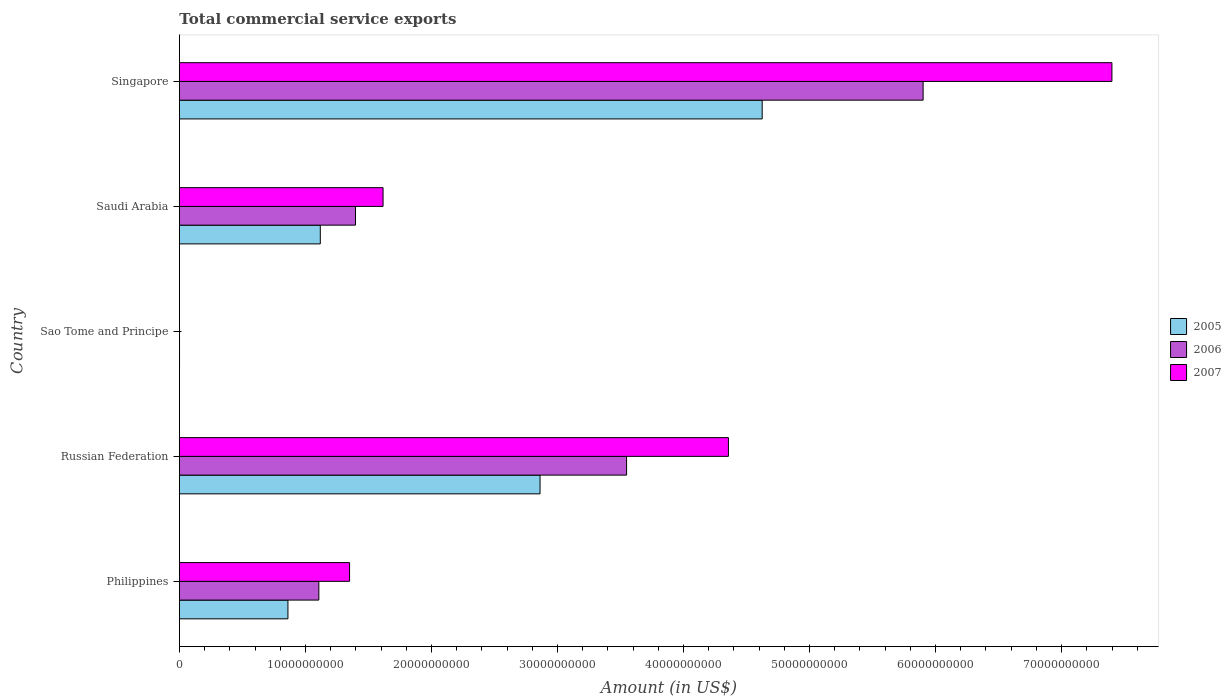How many different coloured bars are there?
Your answer should be compact. 3. Are the number of bars per tick equal to the number of legend labels?
Your answer should be compact. Yes. How many bars are there on the 1st tick from the top?
Ensure brevity in your answer.  3. What is the label of the 1st group of bars from the top?
Keep it short and to the point. Singapore. In how many cases, is the number of bars for a given country not equal to the number of legend labels?
Make the answer very short. 0. What is the total commercial service exports in 2005 in Philippines?
Offer a very short reply. 8.61e+09. Across all countries, what is the maximum total commercial service exports in 2005?
Give a very brief answer. 4.62e+1. Across all countries, what is the minimum total commercial service exports in 2007?
Give a very brief answer. 6.43e+06. In which country was the total commercial service exports in 2007 maximum?
Offer a terse response. Singapore. In which country was the total commercial service exports in 2007 minimum?
Offer a very short reply. Sao Tome and Principe. What is the total total commercial service exports in 2007 in the graph?
Your answer should be compact. 1.47e+11. What is the difference between the total commercial service exports in 2006 in Philippines and that in Singapore?
Give a very brief answer. -4.79e+1. What is the difference between the total commercial service exports in 2005 in Saudi Arabia and the total commercial service exports in 2007 in Philippines?
Make the answer very short. -2.32e+09. What is the average total commercial service exports in 2005 per country?
Give a very brief answer. 1.89e+1. What is the difference between the total commercial service exports in 2006 and total commercial service exports in 2005 in Russian Federation?
Make the answer very short. 6.87e+09. In how many countries, is the total commercial service exports in 2007 greater than 16000000000 US$?
Your response must be concise. 3. What is the ratio of the total commercial service exports in 2005 in Sao Tome and Principe to that in Singapore?
Make the answer very short. 0. Is the total commercial service exports in 2007 in Russian Federation less than that in Singapore?
Your answer should be very brief. Yes. What is the difference between the highest and the second highest total commercial service exports in 2006?
Give a very brief answer. 2.35e+1. What is the difference between the highest and the lowest total commercial service exports in 2005?
Give a very brief answer. 4.62e+1. What does the 2nd bar from the top in Philippines represents?
Ensure brevity in your answer.  2006. Is it the case that in every country, the sum of the total commercial service exports in 2006 and total commercial service exports in 2007 is greater than the total commercial service exports in 2005?
Offer a very short reply. Yes. Are all the bars in the graph horizontal?
Provide a succinct answer. Yes. How many countries are there in the graph?
Give a very brief answer. 5. What is the difference between two consecutive major ticks on the X-axis?
Your response must be concise. 1.00e+1. Are the values on the major ticks of X-axis written in scientific E-notation?
Your answer should be very brief. No. How many legend labels are there?
Offer a very short reply. 3. How are the legend labels stacked?
Provide a succinct answer. Vertical. What is the title of the graph?
Your answer should be compact. Total commercial service exports. What is the Amount (in US$) of 2005 in Philippines?
Provide a short and direct response. 8.61e+09. What is the Amount (in US$) of 2006 in Philippines?
Make the answer very short. 1.11e+1. What is the Amount (in US$) in 2007 in Philippines?
Provide a short and direct response. 1.35e+1. What is the Amount (in US$) in 2005 in Russian Federation?
Ensure brevity in your answer.  2.86e+1. What is the Amount (in US$) in 2006 in Russian Federation?
Keep it short and to the point. 3.55e+1. What is the Amount (in US$) of 2007 in Russian Federation?
Offer a terse response. 4.36e+1. What is the Amount (in US$) of 2005 in Sao Tome and Principe?
Offer a terse response. 8.86e+06. What is the Amount (in US$) in 2006 in Sao Tome and Principe?
Your answer should be very brief. 8.14e+06. What is the Amount (in US$) in 2007 in Sao Tome and Principe?
Offer a very short reply. 6.43e+06. What is the Amount (in US$) in 2005 in Saudi Arabia?
Your response must be concise. 1.12e+1. What is the Amount (in US$) of 2006 in Saudi Arabia?
Offer a very short reply. 1.40e+1. What is the Amount (in US$) in 2007 in Saudi Arabia?
Offer a terse response. 1.62e+1. What is the Amount (in US$) in 2005 in Singapore?
Keep it short and to the point. 4.62e+1. What is the Amount (in US$) in 2006 in Singapore?
Provide a succinct answer. 5.90e+1. What is the Amount (in US$) of 2007 in Singapore?
Offer a terse response. 7.40e+1. Across all countries, what is the maximum Amount (in US$) in 2005?
Your answer should be compact. 4.62e+1. Across all countries, what is the maximum Amount (in US$) of 2006?
Your answer should be compact. 5.90e+1. Across all countries, what is the maximum Amount (in US$) of 2007?
Provide a short and direct response. 7.40e+1. Across all countries, what is the minimum Amount (in US$) of 2005?
Give a very brief answer. 8.86e+06. Across all countries, what is the minimum Amount (in US$) of 2006?
Your answer should be very brief. 8.14e+06. Across all countries, what is the minimum Amount (in US$) in 2007?
Your response must be concise. 6.43e+06. What is the total Amount (in US$) in 2005 in the graph?
Your response must be concise. 9.47e+1. What is the total Amount (in US$) of 2006 in the graph?
Provide a short and direct response. 1.20e+11. What is the total Amount (in US$) in 2007 in the graph?
Make the answer very short. 1.47e+11. What is the difference between the Amount (in US$) in 2005 in Philippines and that in Russian Federation?
Ensure brevity in your answer.  -2.00e+1. What is the difference between the Amount (in US$) in 2006 in Philippines and that in Russian Federation?
Offer a terse response. -2.44e+1. What is the difference between the Amount (in US$) of 2007 in Philippines and that in Russian Federation?
Offer a terse response. -3.01e+1. What is the difference between the Amount (in US$) of 2005 in Philippines and that in Sao Tome and Principe?
Ensure brevity in your answer.  8.60e+09. What is the difference between the Amount (in US$) in 2006 in Philippines and that in Sao Tome and Principe?
Offer a very short reply. 1.11e+1. What is the difference between the Amount (in US$) of 2007 in Philippines and that in Sao Tome and Principe?
Make the answer very short. 1.35e+1. What is the difference between the Amount (in US$) in 2005 in Philippines and that in Saudi Arabia?
Your answer should be compact. -2.57e+09. What is the difference between the Amount (in US$) in 2006 in Philippines and that in Saudi Arabia?
Ensure brevity in your answer.  -2.91e+09. What is the difference between the Amount (in US$) in 2007 in Philippines and that in Saudi Arabia?
Your answer should be very brief. -2.66e+09. What is the difference between the Amount (in US$) in 2005 in Philippines and that in Singapore?
Provide a short and direct response. -3.76e+1. What is the difference between the Amount (in US$) in 2006 in Philippines and that in Singapore?
Offer a terse response. -4.79e+1. What is the difference between the Amount (in US$) of 2007 in Philippines and that in Singapore?
Your response must be concise. -6.05e+1. What is the difference between the Amount (in US$) of 2005 in Russian Federation and that in Sao Tome and Principe?
Ensure brevity in your answer.  2.86e+1. What is the difference between the Amount (in US$) of 2006 in Russian Federation and that in Sao Tome and Principe?
Provide a short and direct response. 3.55e+1. What is the difference between the Amount (in US$) in 2007 in Russian Federation and that in Sao Tome and Principe?
Offer a very short reply. 4.36e+1. What is the difference between the Amount (in US$) of 2005 in Russian Federation and that in Saudi Arabia?
Your response must be concise. 1.74e+1. What is the difference between the Amount (in US$) of 2006 in Russian Federation and that in Saudi Arabia?
Provide a succinct answer. 2.15e+1. What is the difference between the Amount (in US$) in 2007 in Russian Federation and that in Saudi Arabia?
Your response must be concise. 2.74e+1. What is the difference between the Amount (in US$) in 2005 in Russian Federation and that in Singapore?
Make the answer very short. -1.76e+1. What is the difference between the Amount (in US$) of 2006 in Russian Federation and that in Singapore?
Your answer should be compact. -2.35e+1. What is the difference between the Amount (in US$) of 2007 in Russian Federation and that in Singapore?
Offer a terse response. -3.04e+1. What is the difference between the Amount (in US$) of 2005 in Sao Tome and Principe and that in Saudi Arabia?
Your response must be concise. -1.12e+1. What is the difference between the Amount (in US$) in 2006 in Sao Tome and Principe and that in Saudi Arabia?
Keep it short and to the point. -1.40e+1. What is the difference between the Amount (in US$) of 2007 in Sao Tome and Principe and that in Saudi Arabia?
Your answer should be very brief. -1.62e+1. What is the difference between the Amount (in US$) of 2005 in Sao Tome and Principe and that in Singapore?
Offer a very short reply. -4.62e+1. What is the difference between the Amount (in US$) of 2006 in Sao Tome and Principe and that in Singapore?
Keep it short and to the point. -5.90e+1. What is the difference between the Amount (in US$) in 2007 in Sao Tome and Principe and that in Singapore?
Provide a short and direct response. -7.40e+1. What is the difference between the Amount (in US$) of 2005 in Saudi Arabia and that in Singapore?
Give a very brief answer. -3.51e+1. What is the difference between the Amount (in US$) in 2006 in Saudi Arabia and that in Singapore?
Your answer should be compact. -4.50e+1. What is the difference between the Amount (in US$) in 2007 in Saudi Arabia and that in Singapore?
Your answer should be very brief. -5.78e+1. What is the difference between the Amount (in US$) of 2005 in Philippines and the Amount (in US$) of 2006 in Russian Federation?
Provide a short and direct response. -2.69e+1. What is the difference between the Amount (in US$) of 2005 in Philippines and the Amount (in US$) of 2007 in Russian Federation?
Make the answer very short. -3.50e+1. What is the difference between the Amount (in US$) of 2006 in Philippines and the Amount (in US$) of 2007 in Russian Federation?
Your response must be concise. -3.25e+1. What is the difference between the Amount (in US$) in 2005 in Philippines and the Amount (in US$) in 2006 in Sao Tome and Principe?
Offer a very short reply. 8.60e+09. What is the difference between the Amount (in US$) in 2005 in Philippines and the Amount (in US$) in 2007 in Sao Tome and Principe?
Give a very brief answer. 8.60e+09. What is the difference between the Amount (in US$) of 2006 in Philippines and the Amount (in US$) of 2007 in Sao Tome and Principe?
Make the answer very short. 1.11e+1. What is the difference between the Amount (in US$) of 2005 in Philippines and the Amount (in US$) of 2006 in Saudi Arabia?
Provide a succinct answer. -5.36e+09. What is the difference between the Amount (in US$) in 2005 in Philippines and the Amount (in US$) in 2007 in Saudi Arabia?
Give a very brief answer. -7.55e+09. What is the difference between the Amount (in US$) of 2006 in Philippines and the Amount (in US$) of 2007 in Saudi Arabia?
Keep it short and to the point. -5.10e+09. What is the difference between the Amount (in US$) of 2005 in Philippines and the Amount (in US$) of 2006 in Singapore?
Provide a succinct answer. -5.04e+1. What is the difference between the Amount (in US$) of 2005 in Philippines and the Amount (in US$) of 2007 in Singapore?
Your answer should be very brief. -6.54e+1. What is the difference between the Amount (in US$) in 2006 in Philippines and the Amount (in US$) in 2007 in Singapore?
Make the answer very short. -6.29e+1. What is the difference between the Amount (in US$) in 2005 in Russian Federation and the Amount (in US$) in 2006 in Sao Tome and Principe?
Provide a succinct answer. 2.86e+1. What is the difference between the Amount (in US$) in 2005 in Russian Federation and the Amount (in US$) in 2007 in Sao Tome and Principe?
Offer a terse response. 2.86e+1. What is the difference between the Amount (in US$) in 2006 in Russian Federation and the Amount (in US$) in 2007 in Sao Tome and Principe?
Your answer should be very brief. 3.55e+1. What is the difference between the Amount (in US$) in 2005 in Russian Federation and the Amount (in US$) in 2006 in Saudi Arabia?
Your response must be concise. 1.46e+1. What is the difference between the Amount (in US$) in 2005 in Russian Federation and the Amount (in US$) in 2007 in Saudi Arabia?
Ensure brevity in your answer.  1.25e+1. What is the difference between the Amount (in US$) of 2006 in Russian Federation and the Amount (in US$) of 2007 in Saudi Arabia?
Make the answer very short. 1.93e+1. What is the difference between the Amount (in US$) in 2005 in Russian Federation and the Amount (in US$) in 2006 in Singapore?
Give a very brief answer. -3.04e+1. What is the difference between the Amount (in US$) of 2005 in Russian Federation and the Amount (in US$) of 2007 in Singapore?
Your answer should be very brief. -4.54e+1. What is the difference between the Amount (in US$) in 2006 in Russian Federation and the Amount (in US$) in 2007 in Singapore?
Keep it short and to the point. -3.85e+1. What is the difference between the Amount (in US$) in 2005 in Sao Tome and Principe and the Amount (in US$) in 2006 in Saudi Arabia?
Provide a succinct answer. -1.40e+1. What is the difference between the Amount (in US$) of 2005 in Sao Tome and Principe and the Amount (in US$) of 2007 in Saudi Arabia?
Offer a very short reply. -1.62e+1. What is the difference between the Amount (in US$) in 2006 in Sao Tome and Principe and the Amount (in US$) in 2007 in Saudi Arabia?
Provide a succinct answer. -1.62e+1. What is the difference between the Amount (in US$) of 2005 in Sao Tome and Principe and the Amount (in US$) of 2006 in Singapore?
Ensure brevity in your answer.  -5.90e+1. What is the difference between the Amount (in US$) of 2005 in Sao Tome and Principe and the Amount (in US$) of 2007 in Singapore?
Your response must be concise. -7.40e+1. What is the difference between the Amount (in US$) of 2006 in Sao Tome and Principe and the Amount (in US$) of 2007 in Singapore?
Offer a very short reply. -7.40e+1. What is the difference between the Amount (in US$) of 2005 in Saudi Arabia and the Amount (in US$) of 2006 in Singapore?
Make the answer very short. -4.78e+1. What is the difference between the Amount (in US$) of 2005 in Saudi Arabia and the Amount (in US$) of 2007 in Singapore?
Provide a short and direct response. -6.28e+1. What is the difference between the Amount (in US$) of 2006 in Saudi Arabia and the Amount (in US$) of 2007 in Singapore?
Offer a terse response. -6.00e+1. What is the average Amount (in US$) of 2005 per country?
Make the answer very short. 1.89e+1. What is the average Amount (in US$) of 2006 per country?
Keep it short and to the point. 2.39e+1. What is the average Amount (in US$) in 2007 per country?
Provide a short and direct response. 2.94e+1. What is the difference between the Amount (in US$) of 2005 and Amount (in US$) of 2006 in Philippines?
Ensure brevity in your answer.  -2.45e+09. What is the difference between the Amount (in US$) in 2005 and Amount (in US$) in 2007 in Philippines?
Make the answer very short. -4.89e+09. What is the difference between the Amount (in US$) in 2006 and Amount (in US$) in 2007 in Philippines?
Make the answer very short. -2.44e+09. What is the difference between the Amount (in US$) in 2005 and Amount (in US$) in 2006 in Russian Federation?
Make the answer very short. -6.87e+09. What is the difference between the Amount (in US$) in 2005 and Amount (in US$) in 2007 in Russian Federation?
Your answer should be very brief. -1.49e+1. What is the difference between the Amount (in US$) in 2006 and Amount (in US$) in 2007 in Russian Federation?
Offer a terse response. -8.08e+09. What is the difference between the Amount (in US$) in 2005 and Amount (in US$) in 2006 in Sao Tome and Principe?
Offer a terse response. 7.25e+05. What is the difference between the Amount (in US$) of 2005 and Amount (in US$) of 2007 in Sao Tome and Principe?
Keep it short and to the point. 2.43e+06. What is the difference between the Amount (in US$) in 2006 and Amount (in US$) in 2007 in Sao Tome and Principe?
Provide a succinct answer. 1.71e+06. What is the difference between the Amount (in US$) of 2005 and Amount (in US$) of 2006 in Saudi Arabia?
Make the answer very short. -2.79e+09. What is the difference between the Amount (in US$) in 2005 and Amount (in US$) in 2007 in Saudi Arabia?
Provide a short and direct response. -4.98e+09. What is the difference between the Amount (in US$) of 2006 and Amount (in US$) of 2007 in Saudi Arabia?
Make the answer very short. -2.19e+09. What is the difference between the Amount (in US$) of 2005 and Amount (in US$) of 2006 in Singapore?
Provide a succinct answer. -1.28e+1. What is the difference between the Amount (in US$) of 2005 and Amount (in US$) of 2007 in Singapore?
Provide a succinct answer. -2.78e+1. What is the difference between the Amount (in US$) of 2006 and Amount (in US$) of 2007 in Singapore?
Give a very brief answer. -1.50e+1. What is the ratio of the Amount (in US$) of 2005 in Philippines to that in Russian Federation?
Give a very brief answer. 0.3. What is the ratio of the Amount (in US$) of 2006 in Philippines to that in Russian Federation?
Offer a terse response. 0.31. What is the ratio of the Amount (in US$) of 2007 in Philippines to that in Russian Federation?
Ensure brevity in your answer.  0.31. What is the ratio of the Amount (in US$) in 2005 in Philippines to that in Sao Tome and Principe?
Provide a short and direct response. 971.83. What is the ratio of the Amount (in US$) in 2006 in Philippines to that in Sao Tome and Principe?
Offer a terse response. 1360.07. What is the ratio of the Amount (in US$) in 2007 in Philippines to that in Sao Tome and Principe?
Provide a succinct answer. 2100.4. What is the ratio of the Amount (in US$) of 2005 in Philippines to that in Saudi Arabia?
Your response must be concise. 0.77. What is the ratio of the Amount (in US$) in 2006 in Philippines to that in Saudi Arabia?
Keep it short and to the point. 0.79. What is the ratio of the Amount (in US$) of 2007 in Philippines to that in Saudi Arabia?
Offer a very short reply. 0.84. What is the ratio of the Amount (in US$) in 2005 in Philippines to that in Singapore?
Provide a succinct answer. 0.19. What is the ratio of the Amount (in US$) of 2006 in Philippines to that in Singapore?
Offer a terse response. 0.19. What is the ratio of the Amount (in US$) of 2007 in Philippines to that in Singapore?
Offer a terse response. 0.18. What is the ratio of the Amount (in US$) in 2005 in Russian Federation to that in Sao Tome and Principe?
Offer a very short reply. 3229.6. What is the ratio of the Amount (in US$) in 2006 in Russian Federation to that in Sao Tome and Principe?
Your answer should be compact. 4361.62. What is the ratio of the Amount (in US$) in 2007 in Russian Federation to that in Sao Tome and Principe?
Your answer should be compact. 6776.89. What is the ratio of the Amount (in US$) of 2005 in Russian Federation to that in Saudi Arabia?
Your response must be concise. 2.56. What is the ratio of the Amount (in US$) in 2006 in Russian Federation to that in Saudi Arabia?
Your response must be concise. 2.54. What is the ratio of the Amount (in US$) of 2007 in Russian Federation to that in Saudi Arabia?
Your answer should be compact. 2.7. What is the ratio of the Amount (in US$) in 2005 in Russian Federation to that in Singapore?
Provide a succinct answer. 0.62. What is the ratio of the Amount (in US$) in 2006 in Russian Federation to that in Singapore?
Your answer should be compact. 0.6. What is the ratio of the Amount (in US$) in 2007 in Russian Federation to that in Singapore?
Your answer should be very brief. 0.59. What is the ratio of the Amount (in US$) of 2005 in Sao Tome and Principe to that in Saudi Arabia?
Your answer should be compact. 0. What is the ratio of the Amount (in US$) of 2006 in Sao Tome and Principe to that in Saudi Arabia?
Offer a terse response. 0. What is the ratio of the Amount (in US$) in 2006 in Sao Tome and Principe to that in Singapore?
Make the answer very short. 0. What is the ratio of the Amount (in US$) of 2007 in Sao Tome and Principe to that in Singapore?
Your answer should be compact. 0. What is the ratio of the Amount (in US$) of 2005 in Saudi Arabia to that in Singapore?
Your answer should be very brief. 0.24. What is the ratio of the Amount (in US$) of 2006 in Saudi Arabia to that in Singapore?
Your response must be concise. 0.24. What is the ratio of the Amount (in US$) in 2007 in Saudi Arabia to that in Singapore?
Provide a succinct answer. 0.22. What is the difference between the highest and the second highest Amount (in US$) in 2005?
Ensure brevity in your answer.  1.76e+1. What is the difference between the highest and the second highest Amount (in US$) of 2006?
Your answer should be compact. 2.35e+1. What is the difference between the highest and the second highest Amount (in US$) of 2007?
Offer a very short reply. 3.04e+1. What is the difference between the highest and the lowest Amount (in US$) in 2005?
Give a very brief answer. 4.62e+1. What is the difference between the highest and the lowest Amount (in US$) of 2006?
Your answer should be very brief. 5.90e+1. What is the difference between the highest and the lowest Amount (in US$) of 2007?
Offer a terse response. 7.40e+1. 